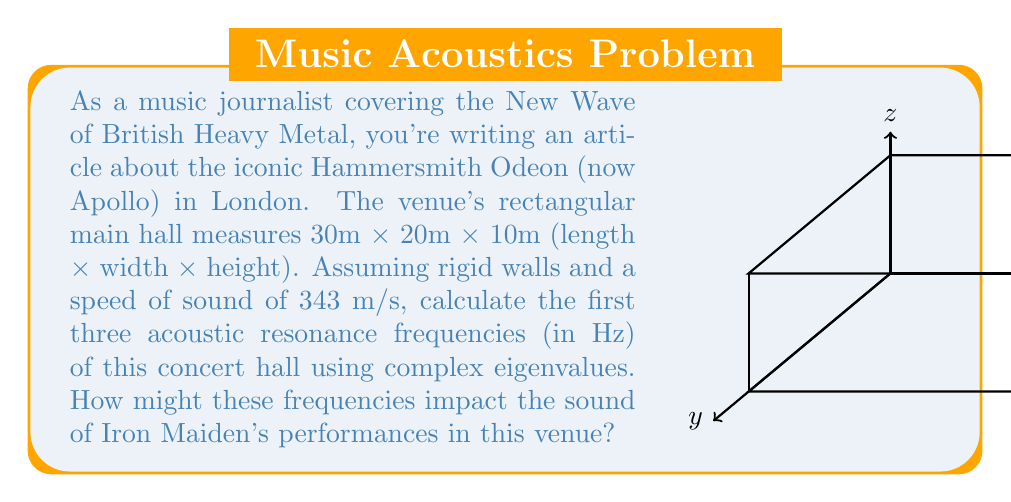Give your solution to this math problem. To solve this problem, we'll use the following steps:

1) The acoustic resonance frequencies for a rectangular room with rigid walls are given by the equation:

   $$f_{lmn} = \frac{c}{2} \sqrt{\left(\frac{l}{L_x}\right)^2 + \left(\frac{m}{L_y}\right)^2 + \left(\frac{n}{L_z}\right)^2}$$

   where $c$ is the speed of sound, $L_x$, $L_y$, and $L_z$ are the room dimensions, and $l$, $m$, and $n$ are non-negative integers.

2) Given:
   $c = 343$ m/s
   $L_x = 30$ m
   $L_y = 20$ m
   $L_z = 10$ m

3) The complex eigenvalues are represented by $\lambda_{lmn} = -i\omega_{lmn}$, where $\omega_{lmn} = 2\pi f_{lmn}$.

4) Let's calculate the first three resonance frequencies:

   a) $f_{100} = \frac{343}{2} \sqrt{\left(\frac{1}{30}\right)^2 + 0 + 0} = 5.72$ Hz

   b) $f_{010} = \frac{343}{2} \sqrt{0 + \left(\frac{1}{20}\right)^2 + 0} = 8.58$ Hz

   c) $f_{001} = \frac{343}{2} \sqrt{0 + 0 + \left(\frac{1}{10}\right)^2} = 17.15$ Hz

5) The corresponding complex eigenvalues are:

   a) $\lambda_{100} = -i(2\pi \cdot 5.72) = -35.94i$
   b) $\lambda_{010} = -i(2\pi \cdot 8.58) = -53.91i$
   c) $\lambda_{001} = -i(2\pi \cdot 17.15) = -107.82i$

These low frequencies could impact Iron Maiden's performances by enhancing the bass and lower mid-range frequencies, potentially adding power to the rhythm section but possibly causing muddiness if not properly managed.
Answer: 5.72 Hz, 8.58 Hz, 17.15 Hz 